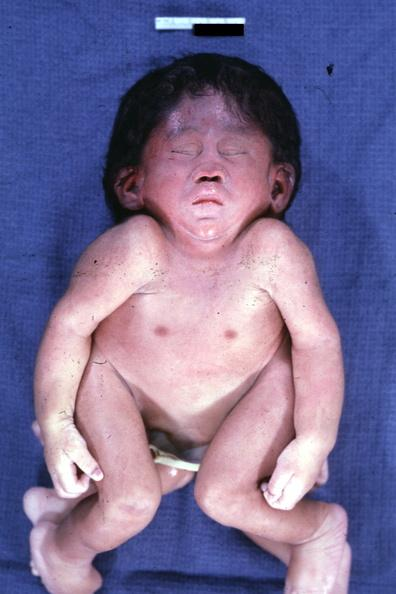what is the best photo to illustrate this case externally?
Answer the question using a single word or phrase. This 